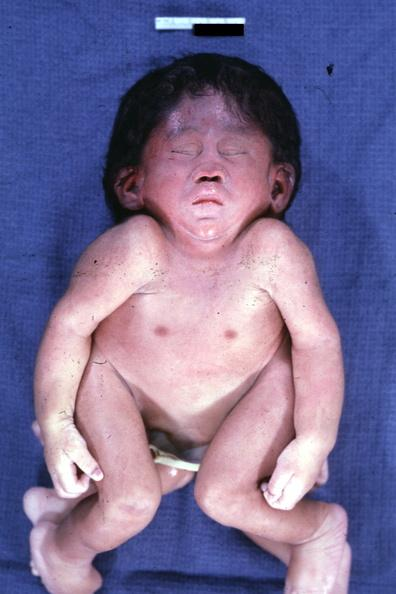what is the best photo to illustrate this case externally?
Answer the question using a single word or phrase. This 